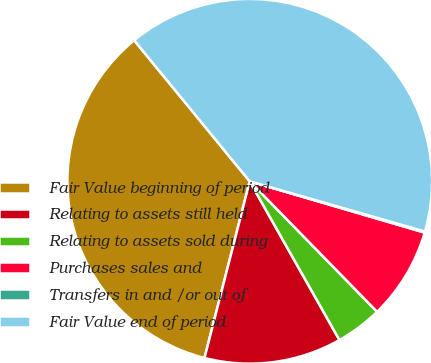Convert chart to OTSL. <chart><loc_0><loc_0><loc_500><loc_500><pie_chart><fcel>Fair Value beginning of period<fcel>Relating to assets still held<fcel>Relating to assets sold during<fcel>Purchases sales and<fcel>Transfers in and /or out of<fcel>Fair Value end of period<nl><fcel>35.09%<fcel>12.18%<fcel>4.12%<fcel>8.15%<fcel>0.1%<fcel>40.37%<nl></chart> 